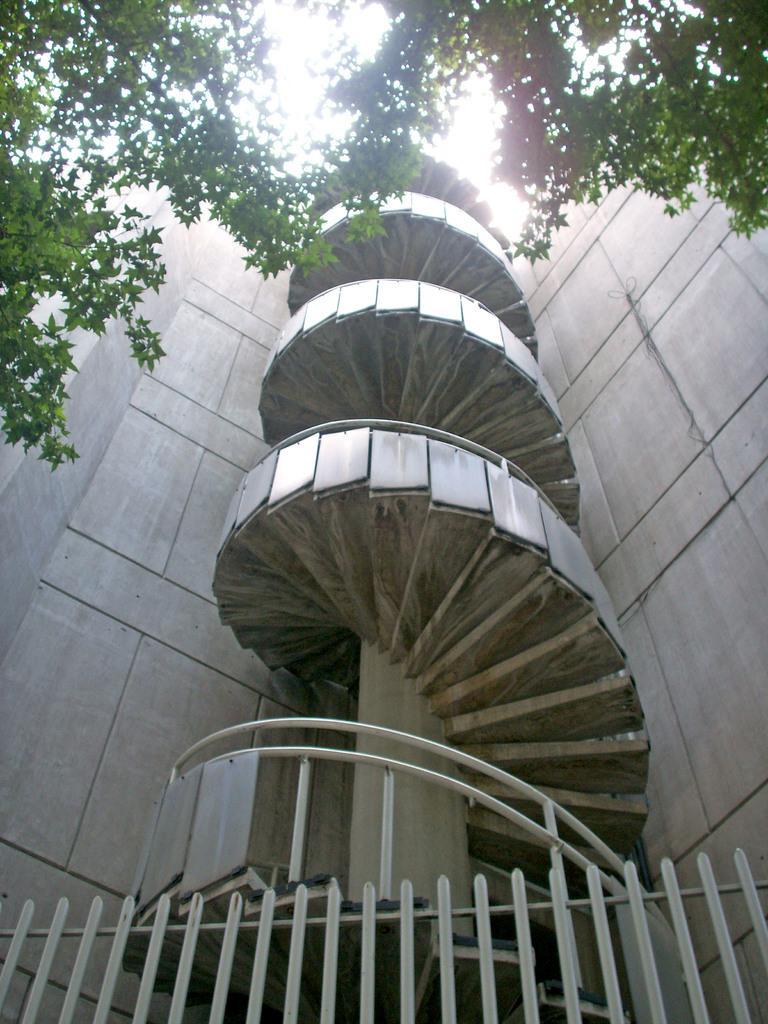Could you give a brief overview of what you see in this image? In this image, I can see a building with stairs and there are trees. At the bottom of the image, I can see iron grilles. In the background there is the sky. 